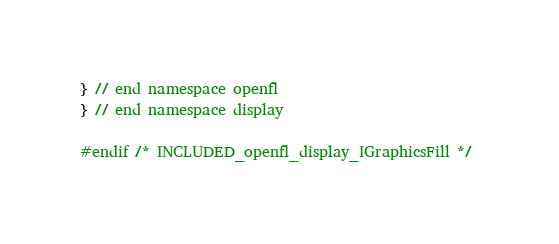Convert code to text. <code><loc_0><loc_0><loc_500><loc_500><_C_>
} // end namespace openfl
} // end namespace display

#endif /* INCLUDED_openfl_display_IGraphicsFill */ 
</code> 